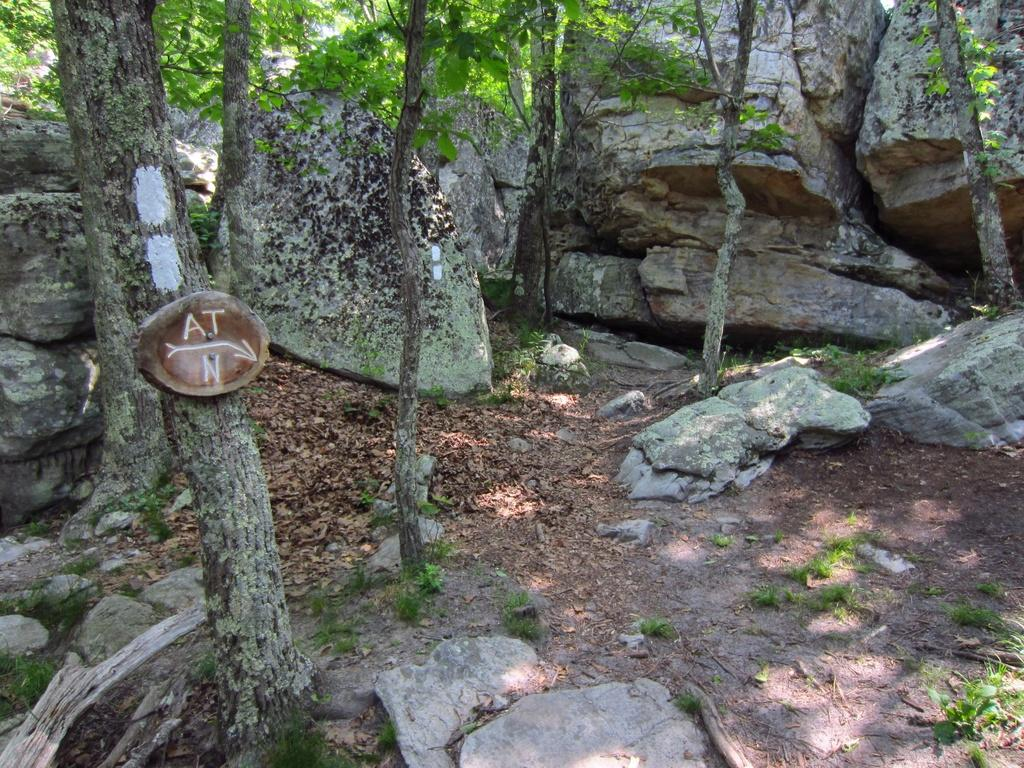What type of vegetation can be seen in the image? There are trees in the image. What other natural elements are present in the image? There are rocks in the image. What is covering the ground in the image? Dry leaves are present on the ground in the image. What type of calculator can be seen in the image? There is no calculator present in the image. 